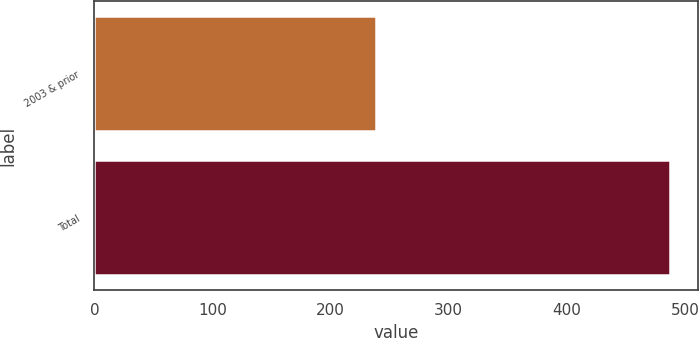Convert chart to OTSL. <chart><loc_0><loc_0><loc_500><loc_500><bar_chart><fcel>2003 & prior<fcel>Total<nl><fcel>238.6<fcel>487.1<nl></chart> 